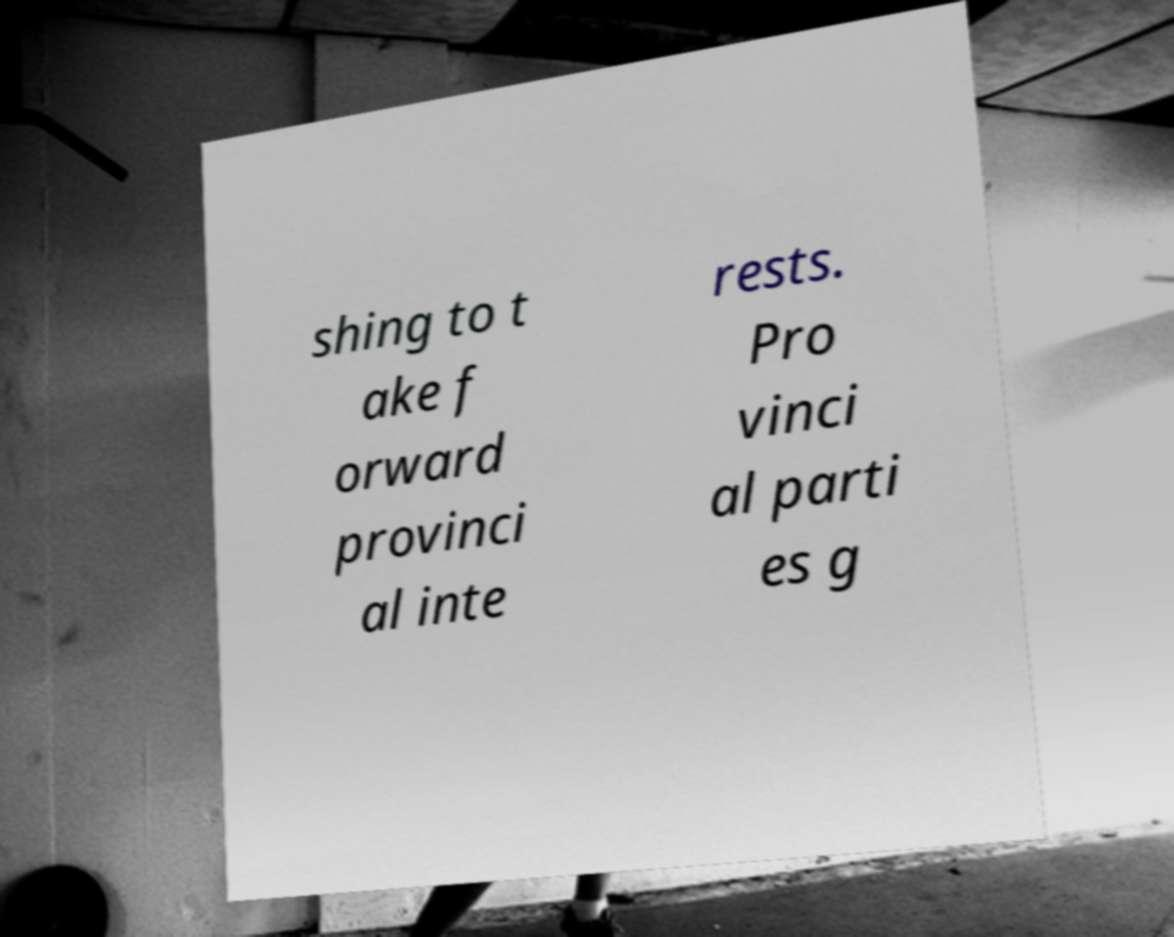What messages or text are displayed in this image? I need them in a readable, typed format. shing to t ake f orward provinci al inte rests. Pro vinci al parti es g 